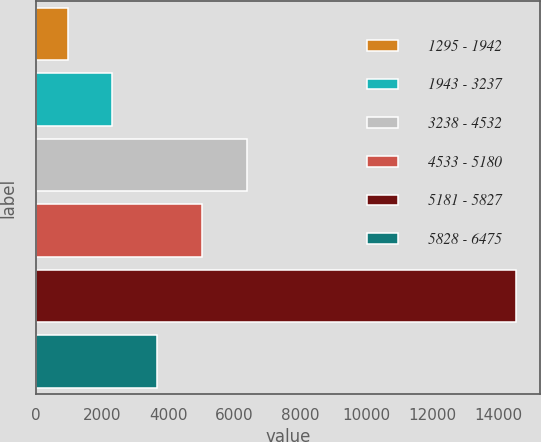Convert chart. <chart><loc_0><loc_0><loc_500><loc_500><bar_chart><fcel>1295 - 1942<fcel>1943 - 3237<fcel>3238 - 4532<fcel>4533 - 5180<fcel>5181 - 5827<fcel>5828 - 6475<nl><fcel>948<fcel>2307.1<fcel>6384.4<fcel>5025.3<fcel>14539<fcel>3666.2<nl></chart> 